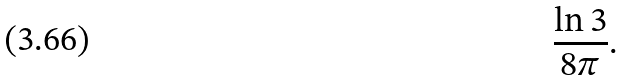Convert formula to latex. <formula><loc_0><loc_0><loc_500><loc_500>\frac { \ln 3 } { 8 \pi } .</formula> 